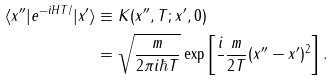Convert formula to latex. <formula><loc_0><loc_0><loc_500><loc_500>\langle x ^ { \prime \prime } | e ^ { - i H T / } | x ^ { \prime } \rangle & \equiv K ( x ^ { \prime \prime } , T ; x ^ { \prime } , 0 ) \\ & = \sqrt { \frac { m } { 2 \pi i \hbar { T } } } \exp { \left [ \frac { i } { } \frac { m } { 2 T } ( x ^ { \prime \prime } - x ^ { \prime } ) ^ { 2 } \right ] } \, .</formula> 